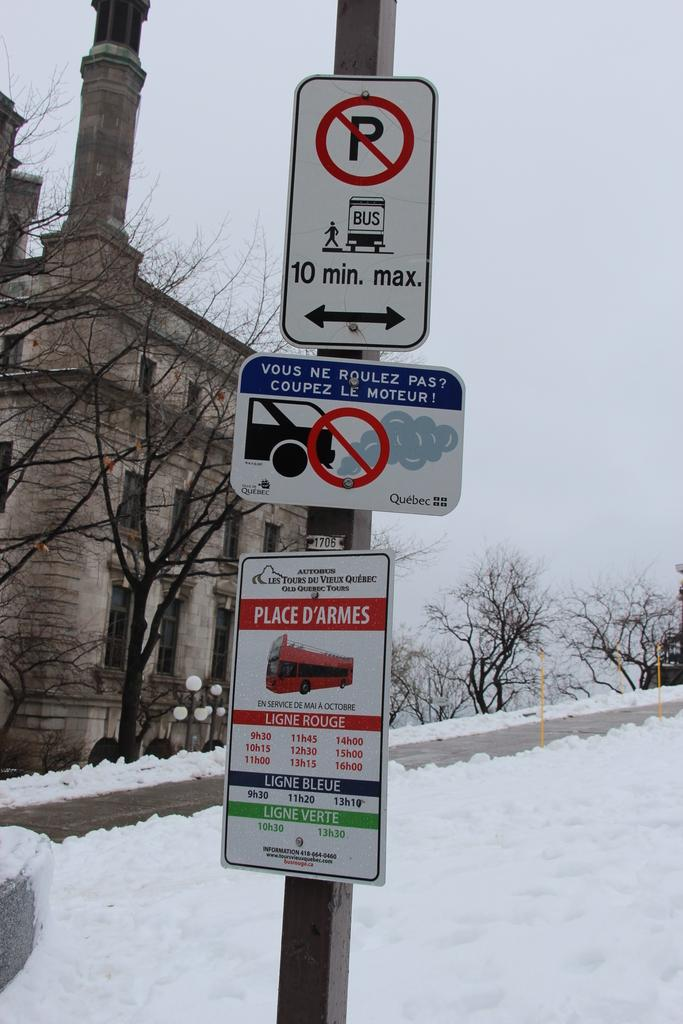<image>
Summarize the visual content of the image. A sign warns there is no parking where the bus will pull in and out. 